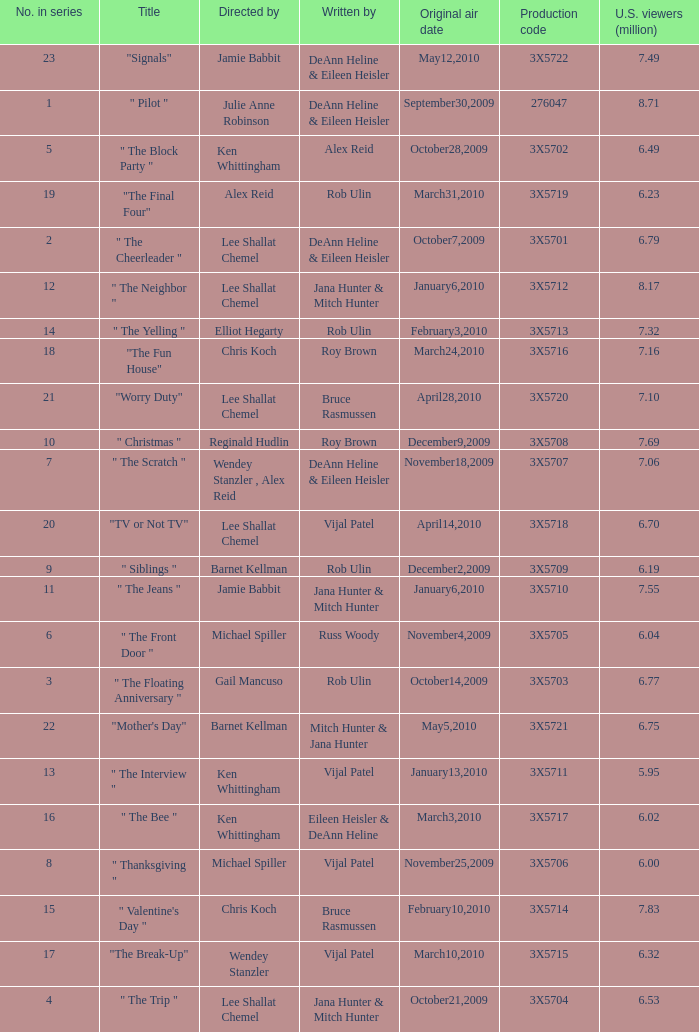How many directors got 6.79 million U.S. viewers from their episodes? 1.0. Write the full table. {'header': ['No. in series', 'Title', 'Directed by', 'Written by', 'Original air date', 'Production code', 'U.S. viewers (million)'], 'rows': [['23', '"Signals"', 'Jamie Babbit', 'DeAnn Heline & Eileen Heisler', 'May12,2010', '3X5722', '7.49'], ['1', '" Pilot "', 'Julie Anne Robinson', 'DeAnn Heline & Eileen Heisler', 'September30,2009', '276047', '8.71'], ['5', '" The Block Party "', 'Ken Whittingham', 'Alex Reid', 'October28,2009', '3X5702', '6.49'], ['19', '"The Final Four"', 'Alex Reid', 'Rob Ulin', 'March31,2010', '3X5719', '6.23'], ['2', '" The Cheerleader "', 'Lee Shallat Chemel', 'DeAnn Heline & Eileen Heisler', 'October7,2009', '3X5701', '6.79'], ['12', '" The Neighbor "', 'Lee Shallat Chemel', 'Jana Hunter & Mitch Hunter', 'January6,2010', '3X5712', '8.17'], ['14', '" The Yelling "', 'Elliot Hegarty', 'Rob Ulin', 'February3,2010', '3X5713', '7.32'], ['18', '"The Fun House"', 'Chris Koch', 'Roy Brown', 'March24,2010', '3X5716', '7.16'], ['21', '"Worry Duty"', 'Lee Shallat Chemel', 'Bruce Rasmussen', 'April28,2010', '3X5720', '7.10'], ['10', '" Christmas "', 'Reginald Hudlin', 'Roy Brown', 'December9,2009', '3X5708', '7.69'], ['7', '" The Scratch "', 'Wendey Stanzler , Alex Reid', 'DeAnn Heline & Eileen Heisler', 'November18,2009', '3X5707', '7.06'], ['20', '"TV or Not TV"', 'Lee Shallat Chemel', 'Vijal Patel', 'April14,2010', '3X5718', '6.70'], ['9', '" Siblings "', 'Barnet Kellman', 'Rob Ulin', 'December2,2009', '3X5709', '6.19'], ['11', '" The Jeans "', 'Jamie Babbit', 'Jana Hunter & Mitch Hunter', 'January6,2010', '3X5710', '7.55'], ['6', '" The Front Door "', 'Michael Spiller', 'Russ Woody', 'November4,2009', '3X5705', '6.04'], ['3', '" The Floating Anniversary "', 'Gail Mancuso', 'Rob Ulin', 'October14,2009', '3X5703', '6.77'], ['22', '"Mother\'s Day"', 'Barnet Kellman', 'Mitch Hunter & Jana Hunter', 'May5,2010', '3X5721', '6.75'], ['13', '" The Interview "', 'Ken Whittingham', 'Vijal Patel', 'January13,2010', '3X5711', '5.95'], ['16', '" The Bee "', 'Ken Whittingham', 'Eileen Heisler & DeAnn Heline', 'March3,2010', '3X5717', '6.02'], ['8', '" Thanksgiving "', 'Michael Spiller', 'Vijal Patel', 'November25,2009', '3X5706', '6.00'], ['15', '" Valentine\'s Day "', 'Chris Koch', 'Bruce Rasmussen', 'February10,2010', '3X5714', '7.83'], ['17', '"The Break-Up"', 'Wendey Stanzler', 'Vijal Patel', 'March10,2010', '3X5715', '6.32'], ['4', '" The Trip "', 'Lee Shallat Chemel', 'Jana Hunter & Mitch Hunter', 'October21,2009', '3X5704', '6.53']]} 